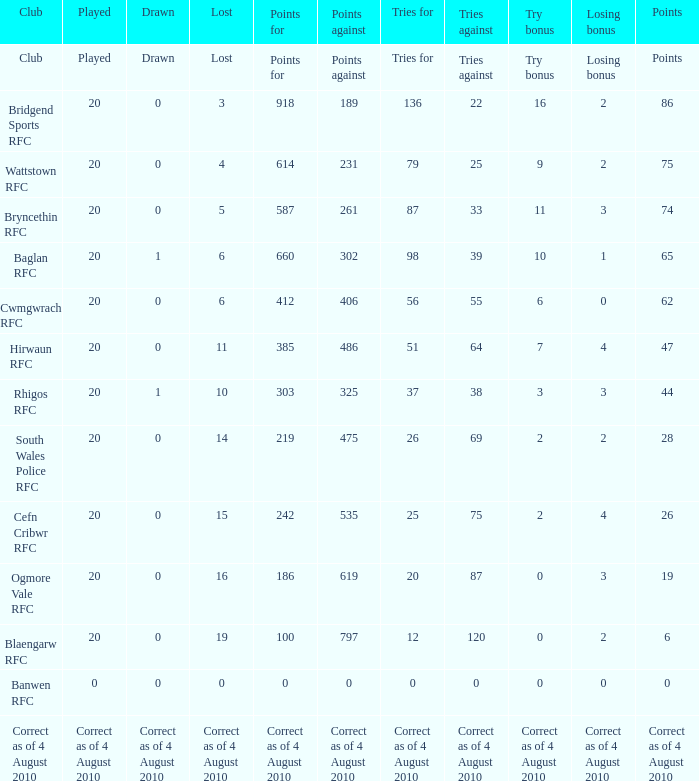What is the points against when drawn is drawn? Points against. 